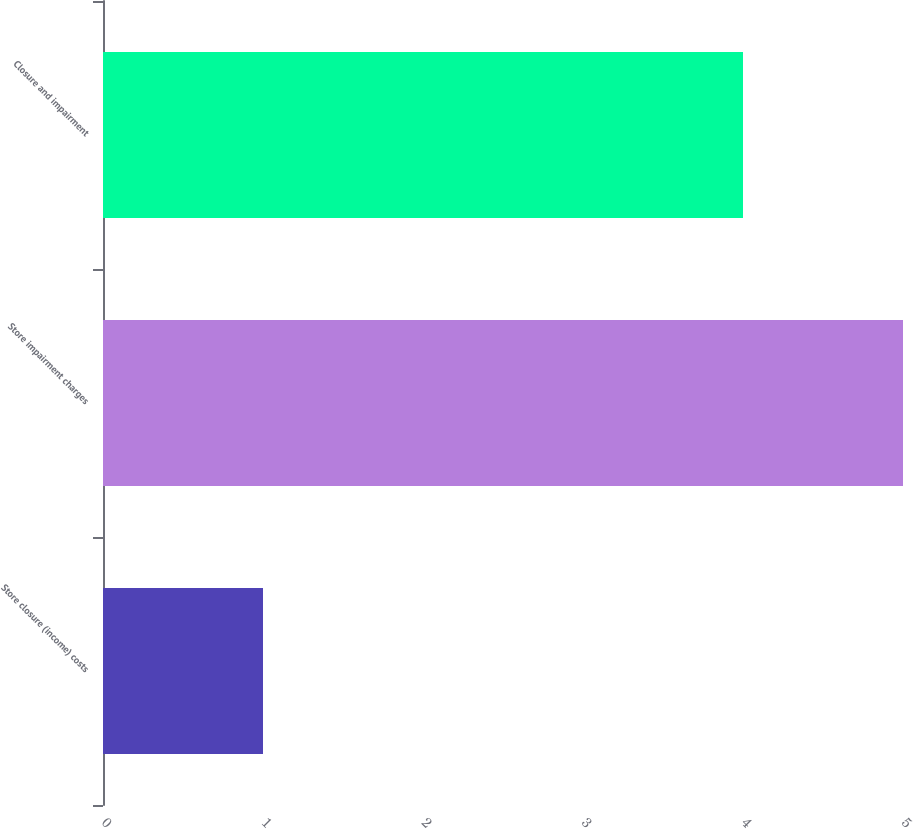Convert chart. <chart><loc_0><loc_0><loc_500><loc_500><bar_chart><fcel>Store closure (income) costs<fcel>Store impairment charges<fcel>Closure and impairment<nl><fcel>1<fcel>5<fcel>4<nl></chart> 